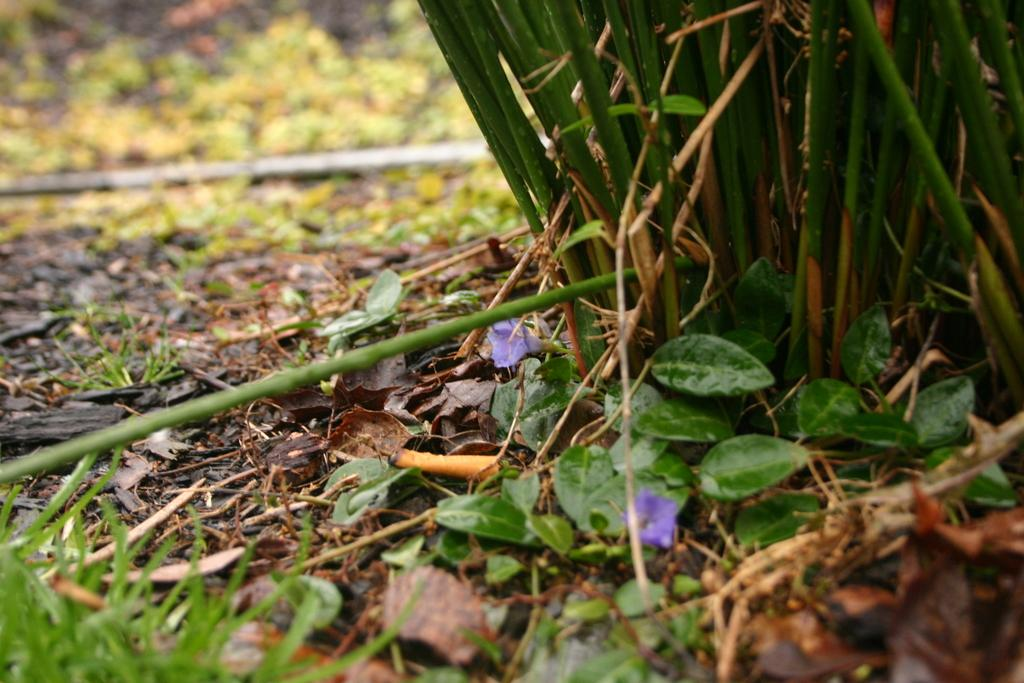What type of surface is visible in the image? There is grass on the surface in the image. What can be found among the grass in the image? There are dry leaves and flowers in the image. What other objects are present in the image? There are wooden sticks in the image. What type of toy can be seen playing with the wooden sticks in the image? There is no toy present in the image; it only features grass, dry leaves, flowers, and wooden sticks. 